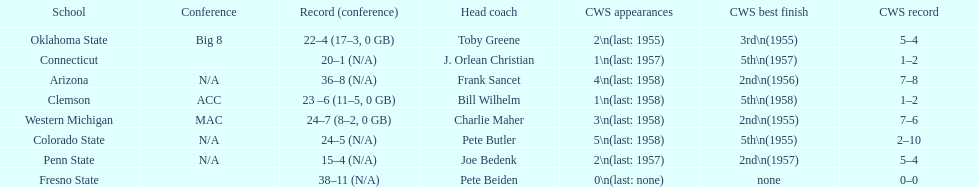What are all the schools? Arizona, Clemson, Colorado State, Connecticut, Fresno State, Oklahoma State, Penn State, Western Michigan. Which are clemson and western michigan? Clemson, Western Michigan. Of these, which has more cws appearances? Western Michigan. 